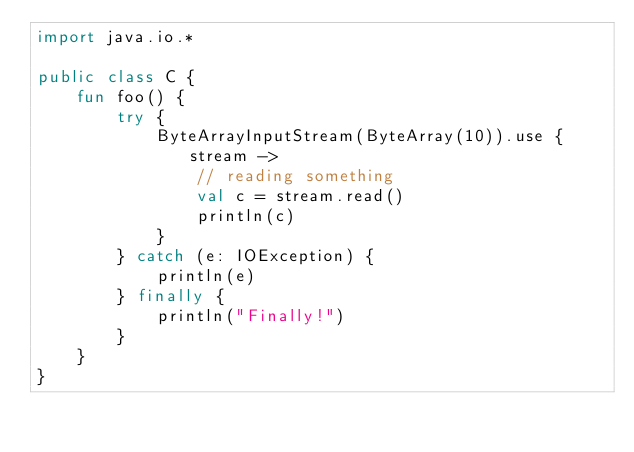<code> <loc_0><loc_0><loc_500><loc_500><_Kotlin_>import java.io.*

public class C {
    fun foo() {
        try {
            ByteArrayInputStream(ByteArray(10)).use { stream ->
                // reading something
                val c = stream.read()
                println(c)
            }
        } catch (e: IOException) {
            println(e)
        } finally {
            println("Finally!")
        }
    }
}</code> 